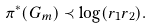Convert formula to latex. <formula><loc_0><loc_0><loc_500><loc_500>\pi ^ { * } ( G _ { m } ) \prec \log ( r _ { 1 } r _ { 2 } ) .</formula> 